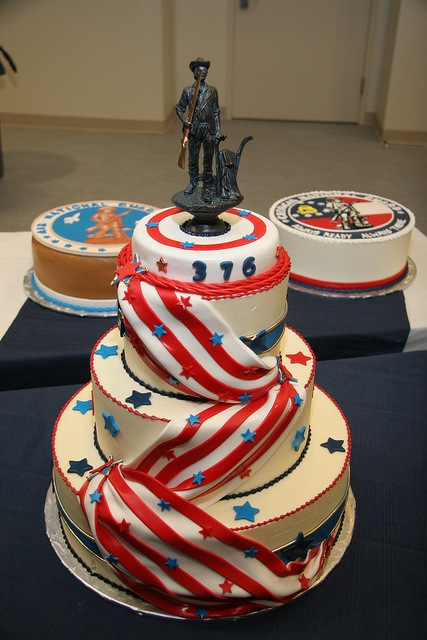Describe the objects in this image and their specific colors. I can see dining table in black, tan, darkgray, and brown tones, cake in black, tan, brown, and maroon tones, cake in black, darkgray, tan, and gray tones, and cake in black, brown, teal, maroon, and darkgray tones in this image. 